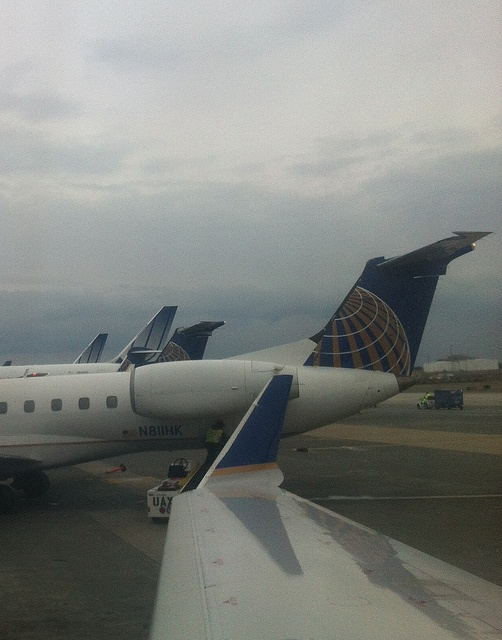Describe the objects in this image and their specific colors. I can see airplane in lightgray, gray, and black tones, airplane in lightgray, black, gray, and darkgray tones, airplane in lightgray, gray, darkgray, black, and darkblue tones, truck in lightgray, black, and gray tones, and truck in lightgray, black, gray, and darkgreen tones in this image. 